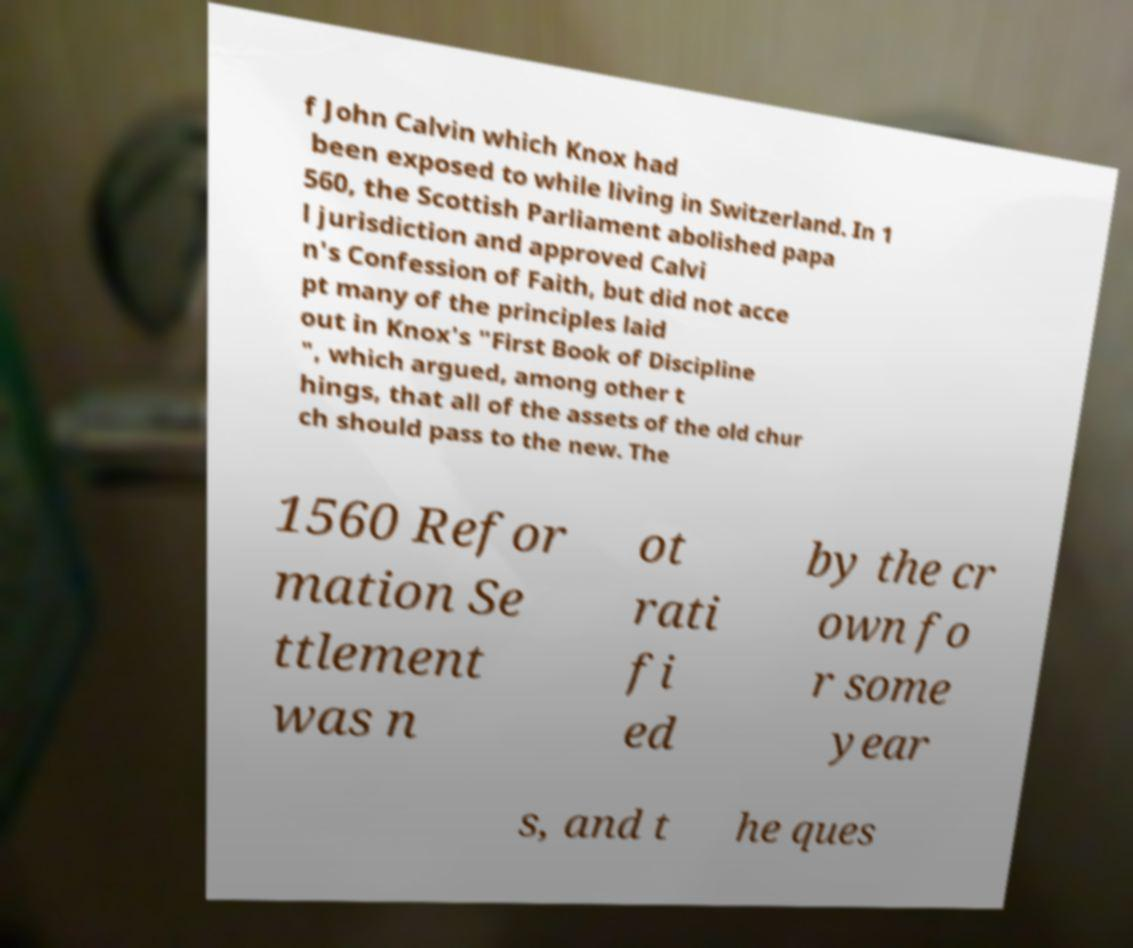Please read and relay the text visible in this image. What does it say? f John Calvin which Knox had been exposed to while living in Switzerland. In 1 560, the Scottish Parliament abolished papa l jurisdiction and approved Calvi n's Confession of Faith, but did not acce pt many of the principles laid out in Knox's "First Book of Discipline ", which argued, among other t hings, that all of the assets of the old chur ch should pass to the new. The 1560 Refor mation Se ttlement was n ot rati fi ed by the cr own fo r some year s, and t he ques 